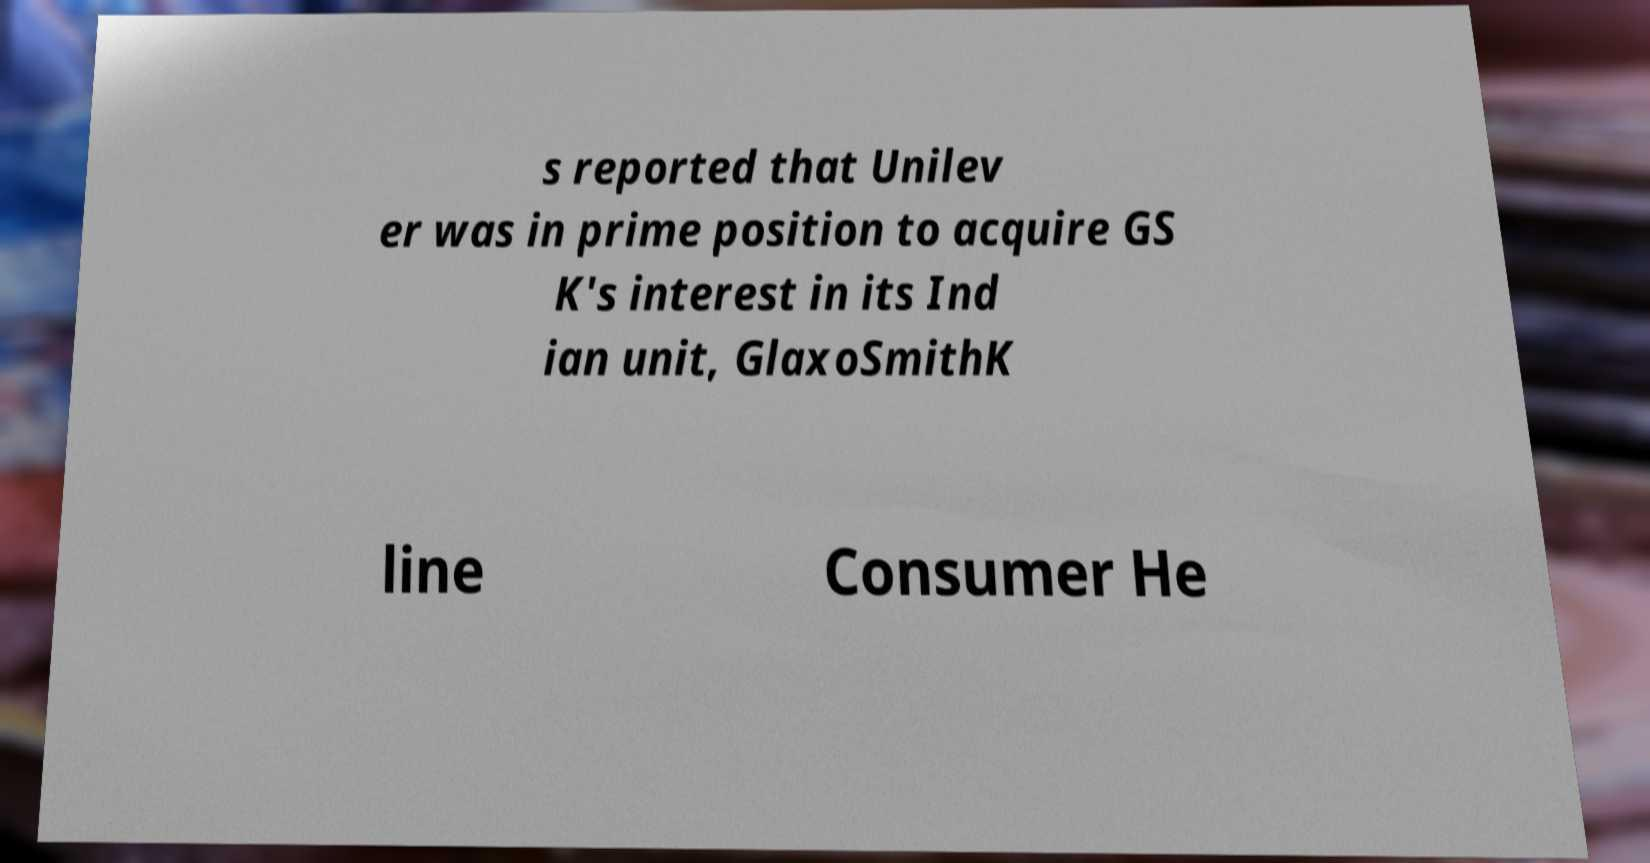Please read and relay the text visible in this image. What does it say? s reported that Unilev er was in prime position to acquire GS K's interest in its Ind ian unit, GlaxoSmithK line Consumer He 